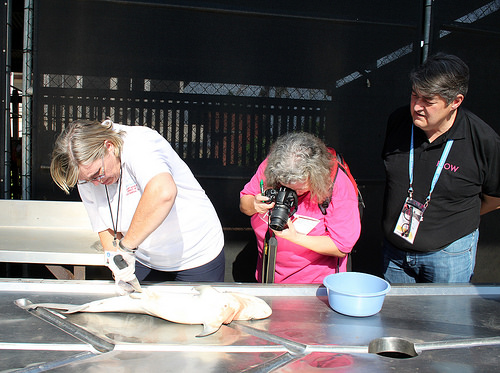<image>
Can you confirm if the fish is on the table? Yes. Looking at the image, I can see the fish is positioned on top of the table, with the table providing support. 